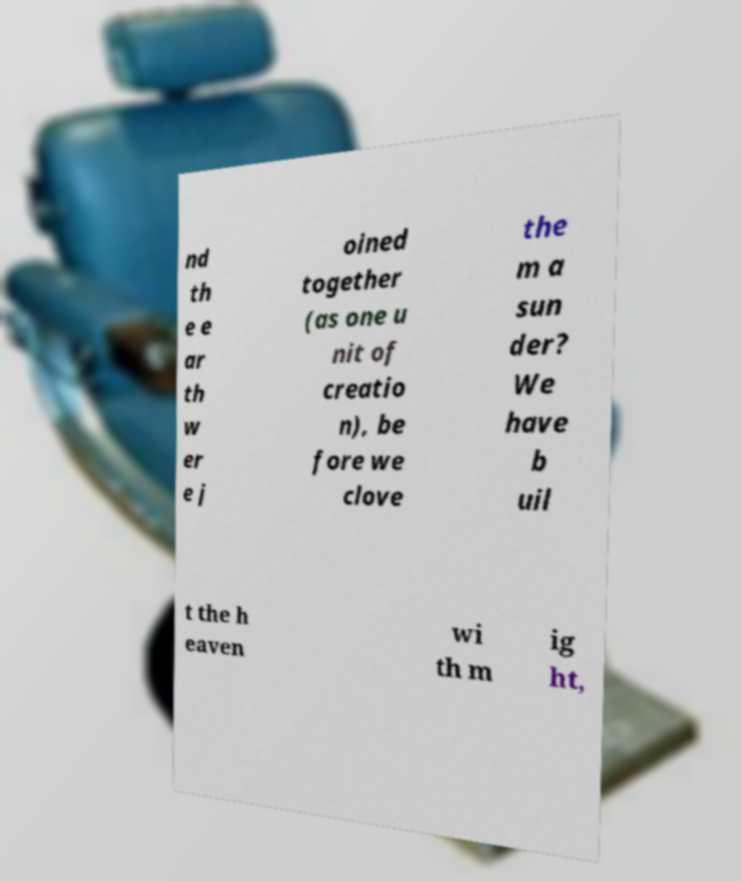Please identify and transcribe the text found in this image. nd th e e ar th w er e j oined together (as one u nit of creatio n), be fore we clove the m a sun der? We have b uil t the h eaven wi th m ig ht, 